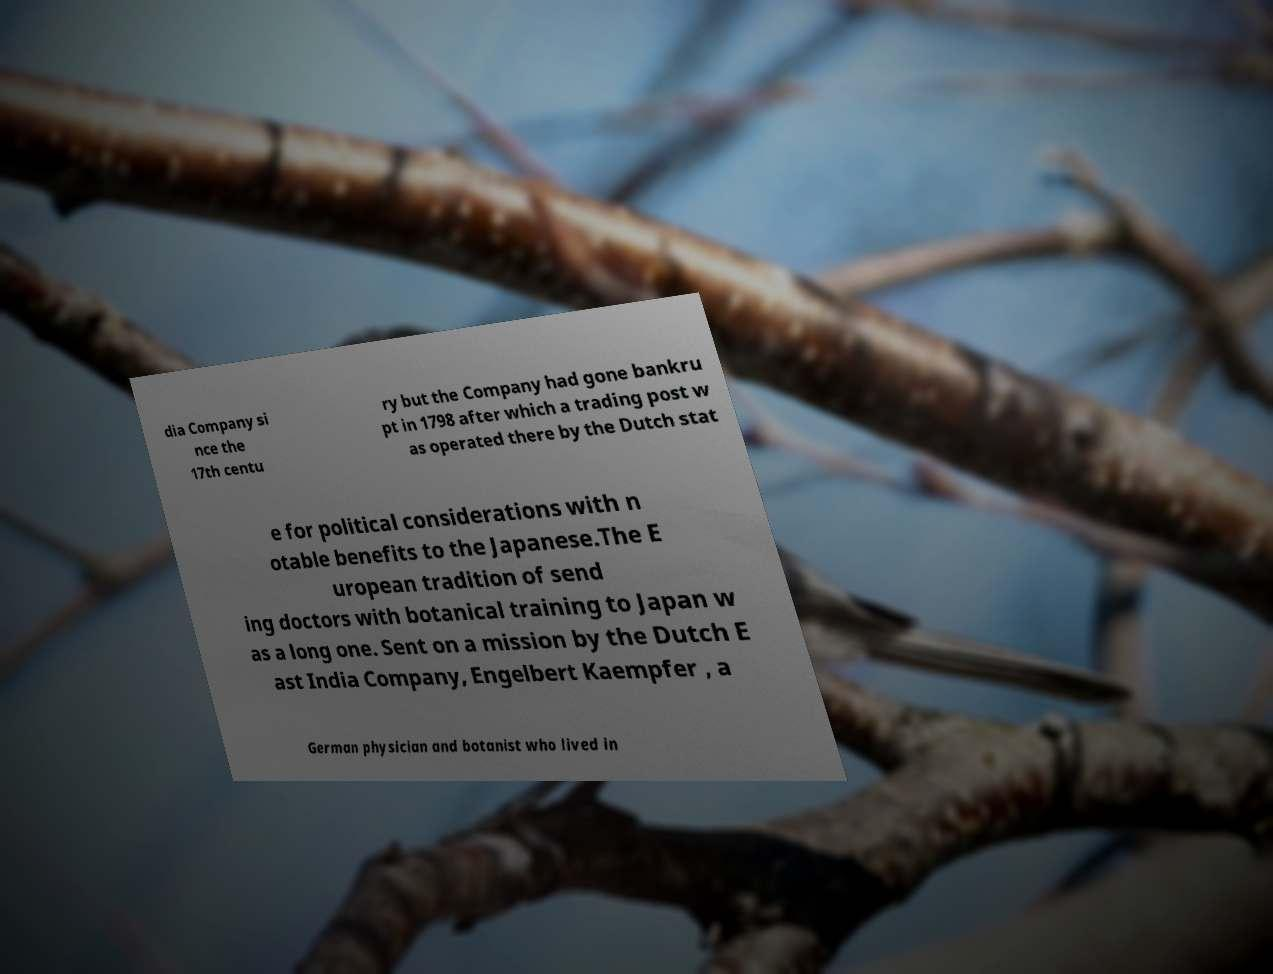Could you assist in decoding the text presented in this image and type it out clearly? dia Company si nce the 17th centu ry but the Company had gone bankru pt in 1798 after which a trading post w as operated there by the Dutch stat e for political considerations with n otable benefits to the Japanese.The E uropean tradition of send ing doctors with botanical training to Japan w as a long one. Sent on a mission by the Dutch E ast India Company, Engelbert Kaempfer , a German physician and botanist who lived in 